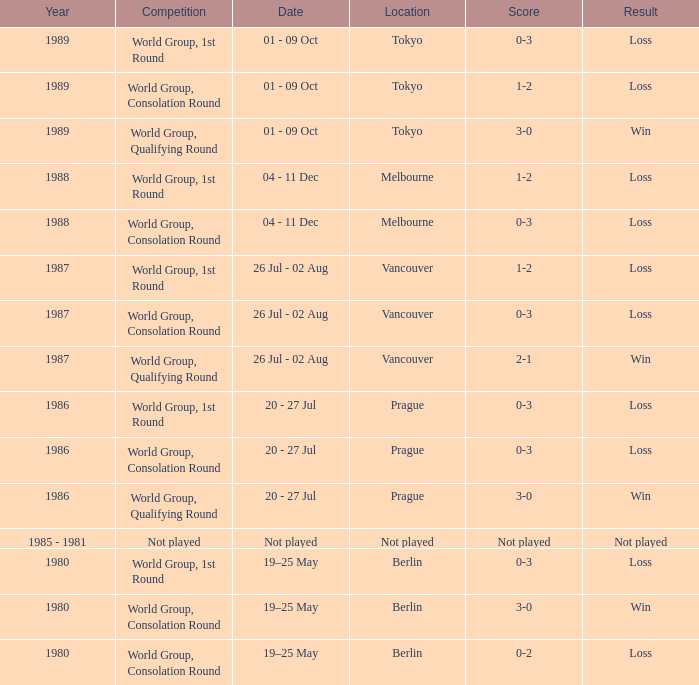What is the contest in tokyo with the outcome being a loss? World Group, 1st Round, World Group, Consolation Round. 